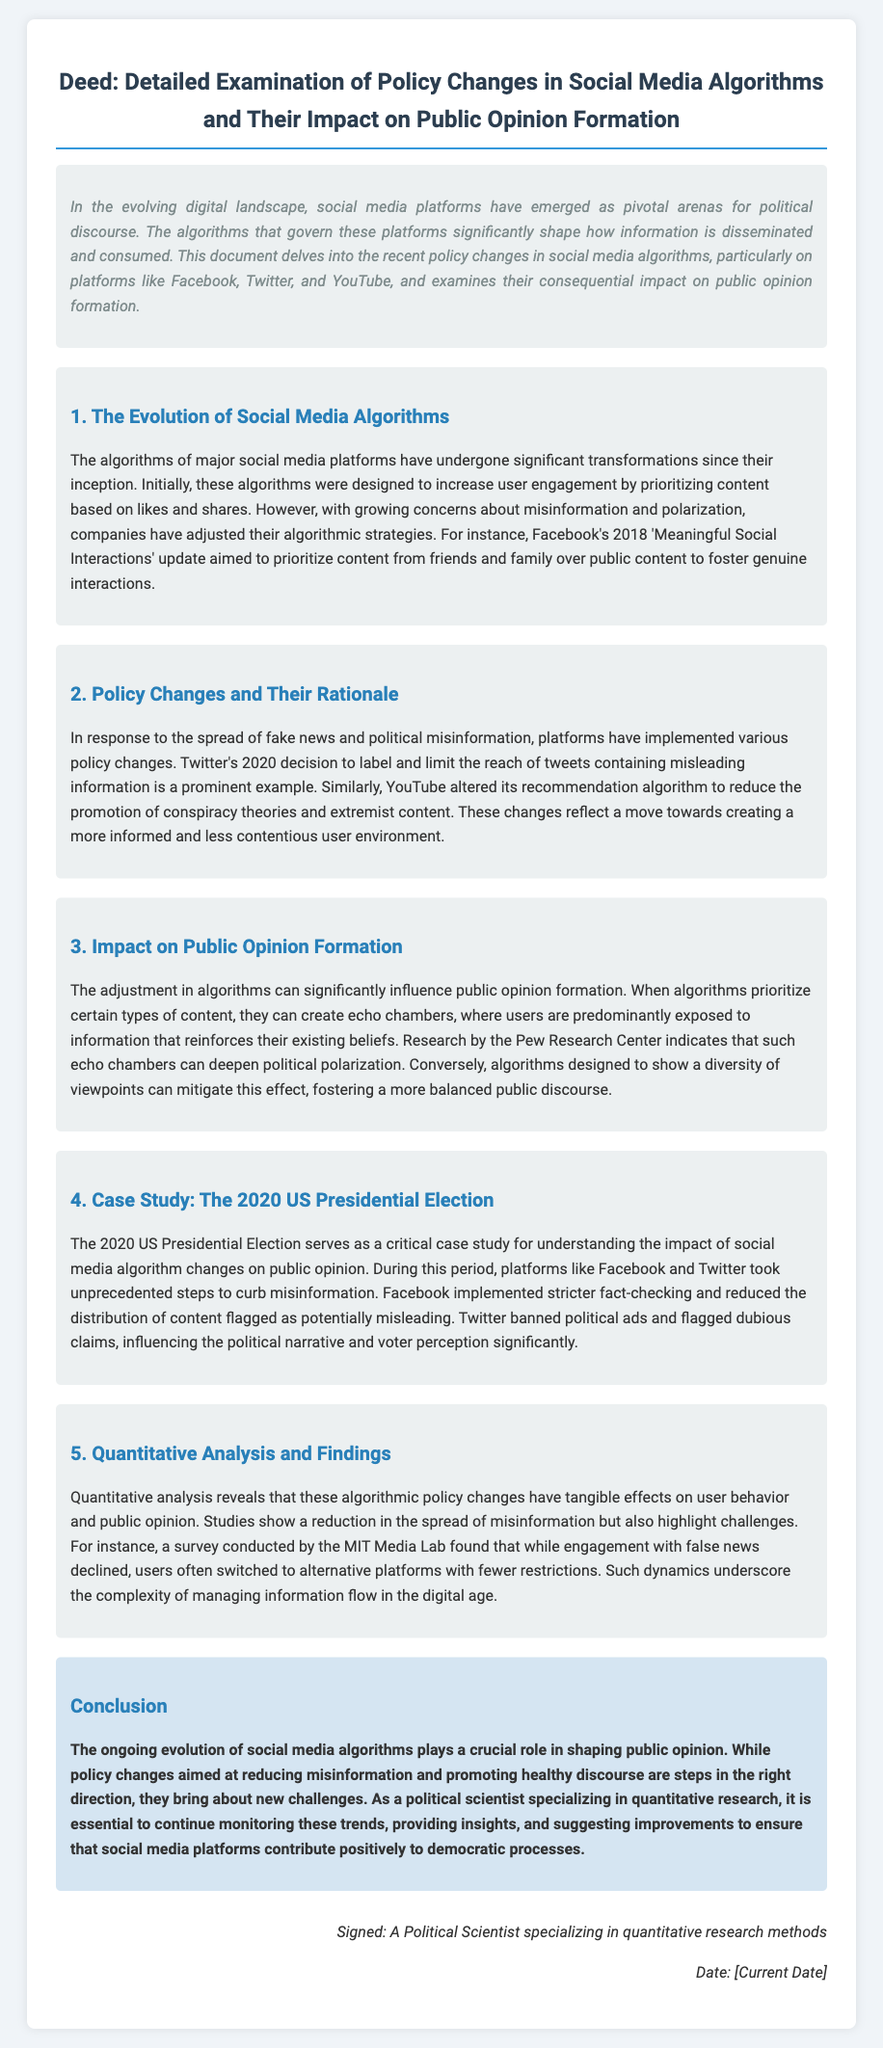What is the title of the document? The title is explicitly stated at the beginning of the document and summarizes the content effectively.
Answer: Detailed Examination of Policy Changes in Social Media Algorithms and Their Impact on Public Opinion Formation Which major social media platforms are mentioned? The document lists specific social media platforms that are the focus of the examination regarding algorithm changes.
Answer: Facebook, Twitter, YouTube What significant algorithm update did Facebook implement in 2018? The document discusses a particular update made by Facebook which is crucial in understanding their algorithm changes.
Answer: Meaningful Social Interactions What was Twitter's 2020 decision regarding misleading information? This decision is highlighted as a notable example of policy change in the context of misinformation.
Answer: Label and limit the reach of tweets What impact do echo chambers have on political belief? The document indicates the role echo chambers play in shaping political discourse among users.
Answer: Deepen political polarization What case study is used to illustrate the impact of social media algorithms? The document specifically refers to a critical event in political history relevant to social media's influence.
Answer: The 2020 US Presidential Election What type of analysis is emphasized in understanding the effects of algorithm changes? The document identifies the method used to evaluate the impact of algorithm adjustments on user behavior.
Answer: Quantitative analysis What does the conclusion suggest about the future of social media algorithms? The conclusion summarizes the ongoing challenges and the need for continual assessment of social media's role in politics.
Answer: Monitor these trends 